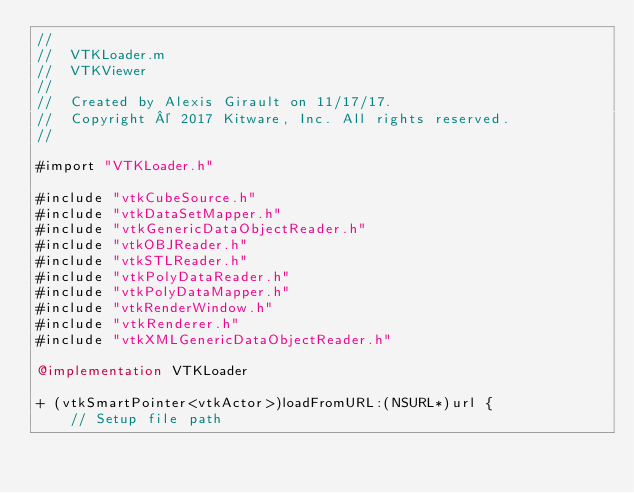<code> <loc_0><loc_0><loc_500><loc_500><_ObjectiveC_>//
//  VTKLoader.m
//  VTKViewer
//
//  Created by Alexis Girault on 11/17/17.
//  Copyright © 2017 Kitware, Inc. All rights reserved.
//

#import "VTKLoader.h"

#include "vtkCubeSource.h"
#include "vtkDataSetMapper.h"
#include "vtkGenericDataObjectReader.h"
#include "vtkOBJReader.h"
#include "vtkSTLReader.h"
#include "vtkPolyDataReader.h"
#include "vtkPolyDataMapper.h"
#include "vtkRenderWindow.h"
#include "vtkRenderer.h"
#include "vtkXMLGenericDataObjectReader.h"

@implementation VTKLoader

+ (vtkSmartPointer<vtkActor>)loadFromURL:(NSURL*)url {
    // Setup file path</code> 